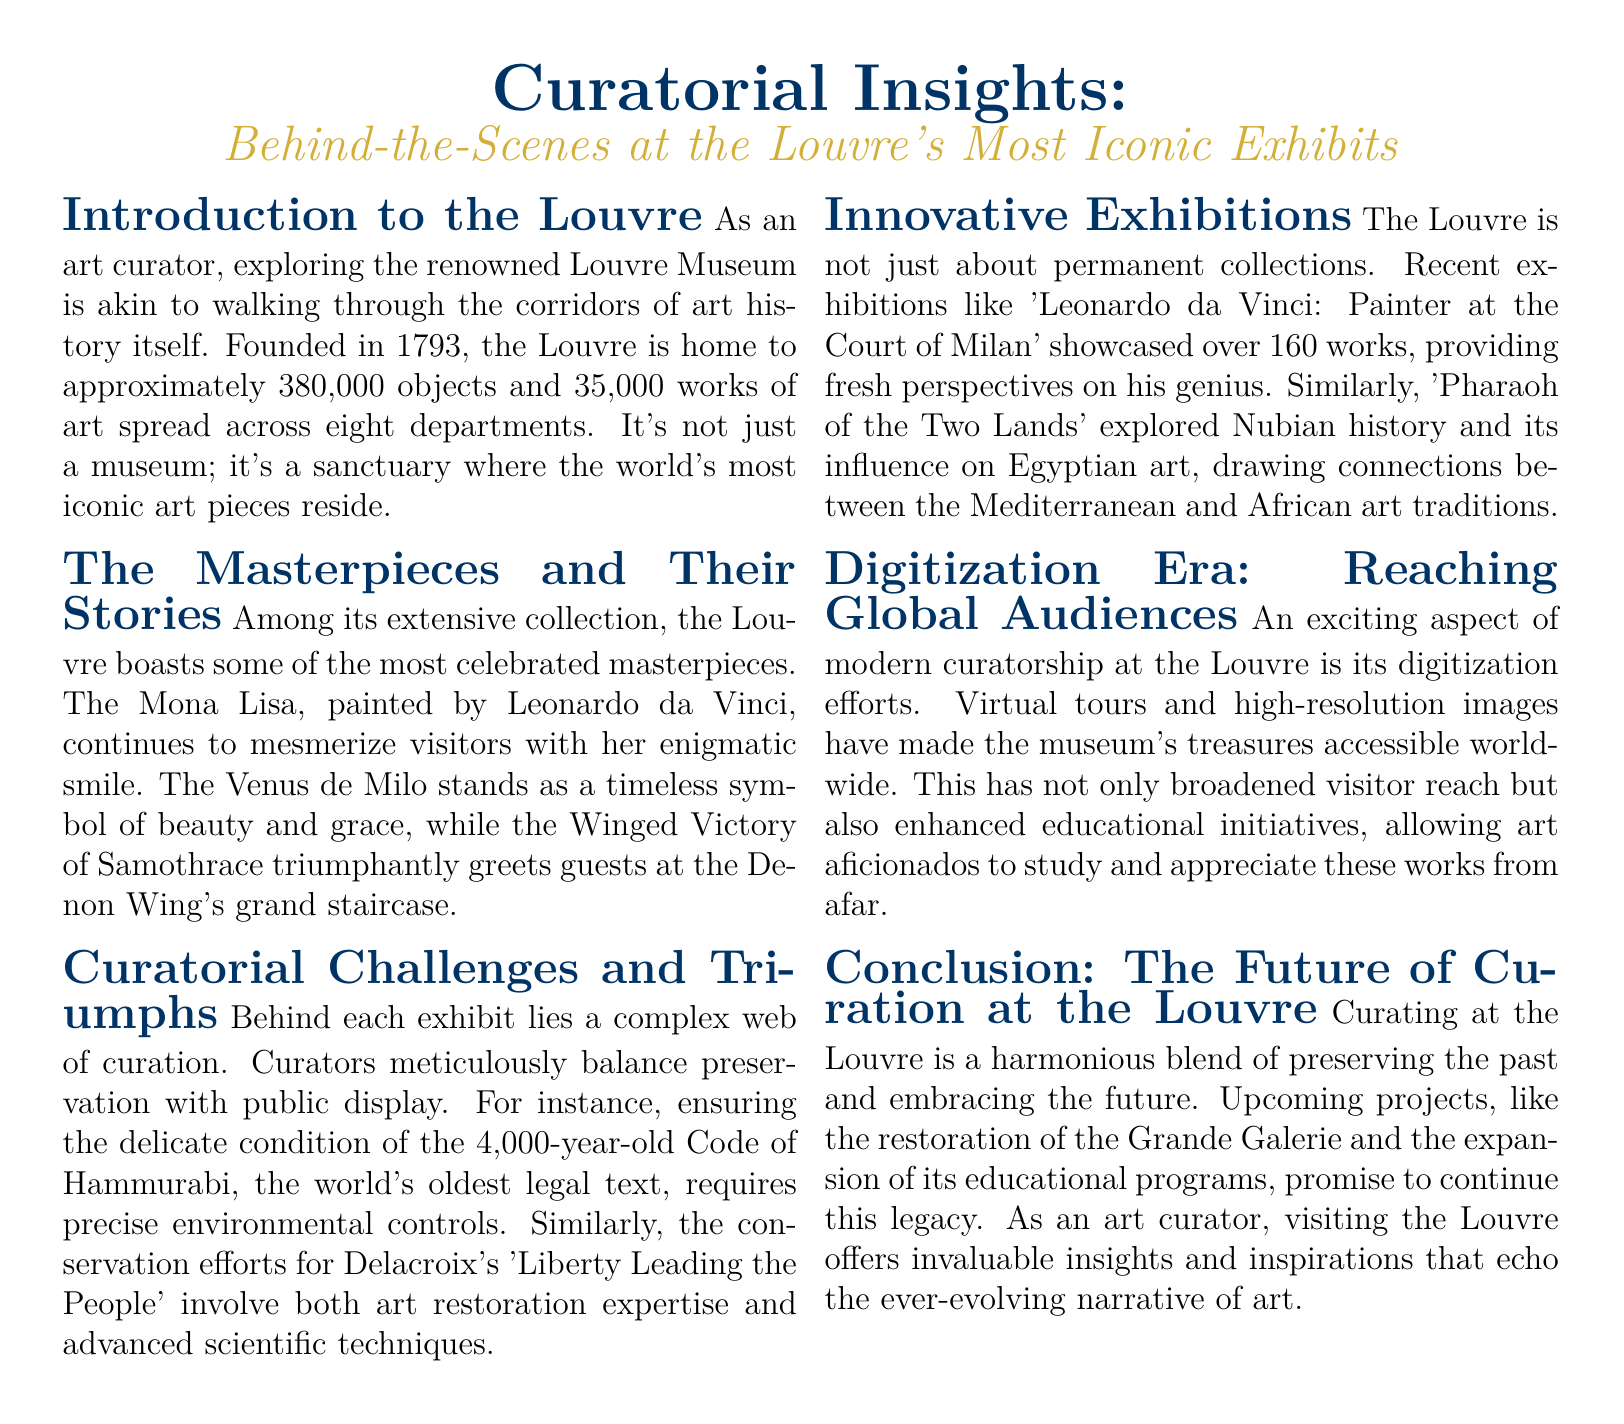What year was the Louvre founded? The document states that the Louvre was founded in 1793.
Answer: 1793 How many objects are housed in the Louvre? The document mentions that the Louvre is home to approximately 380,000 objects.
Answer: 380,000 What is the title of the famous painting by Leonardo da Vinci? The document identifies the Mona Lisa as a celebrated masterpiece by Leonardo da Vinci.
Answer: Mona Lisa Which ancient artifact requires precise environmental controls? The document refers to the 4,000-year-old Code of Hammurabi as needing precise environmental controls for preservation.
Answer: Code of Hammurabi Name one recent exhibition mentioned in the document. The document lists 'Leonardo da Vinci: Painter at the Court of Milan' as a recent exhibition.
Answer: Leonardo da Vinci: Painter at the Court of Milan What does the Louvre's digitization efforts aim to improve? The document indicates that digitization efforts aim to broaden visitor reach and enhance educational initiatives.
Answer: Accessibility How does the document describe the balance curators must maintain? The document states that curators must balance preservation with public display.
Answer: Preservation and public display What iconic piece greets guests at the Denon Wing's grand staircase? The document mentions the Winged Victory of Samothrace as the piece that greets guests at the Denon Wing's grand staircase.
Answer: Winged Victory of Samothrace What is the significance of the upcoming projects at the Louvre? The document highlights that upcoming projects promise to continue the museum's legacy of curation.
Answer: Continue the legacy 